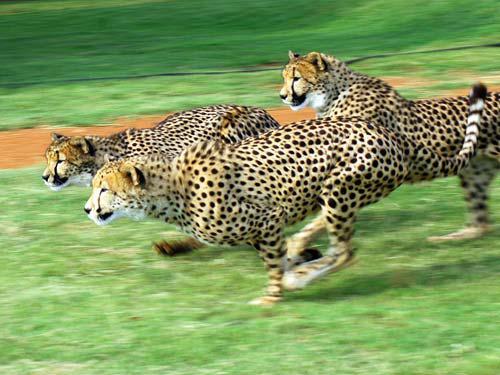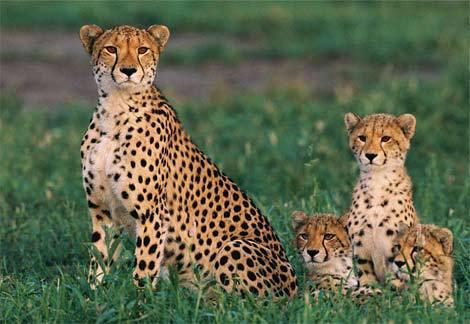The first image is the image on the left, the second image is the image on the right. Analyze the images presented: Is the assertion "At least one of the animals is movie fast." valid? Answer yes or no. Yes. The first image is the image on the left, the second image is the image on the right. Evaluate the accuracy of this statement regarding the images: "The left image contains at least three spotted wild cats.". Is it true? Answer yes or no. Yes. 